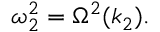<formula> <loc_0><loc_0><loc_500><loc_500>\omega _ { 2 } ^ { 2 } = \Omega ^ { 2 } ( k _ { 2 } ) .</formula> 